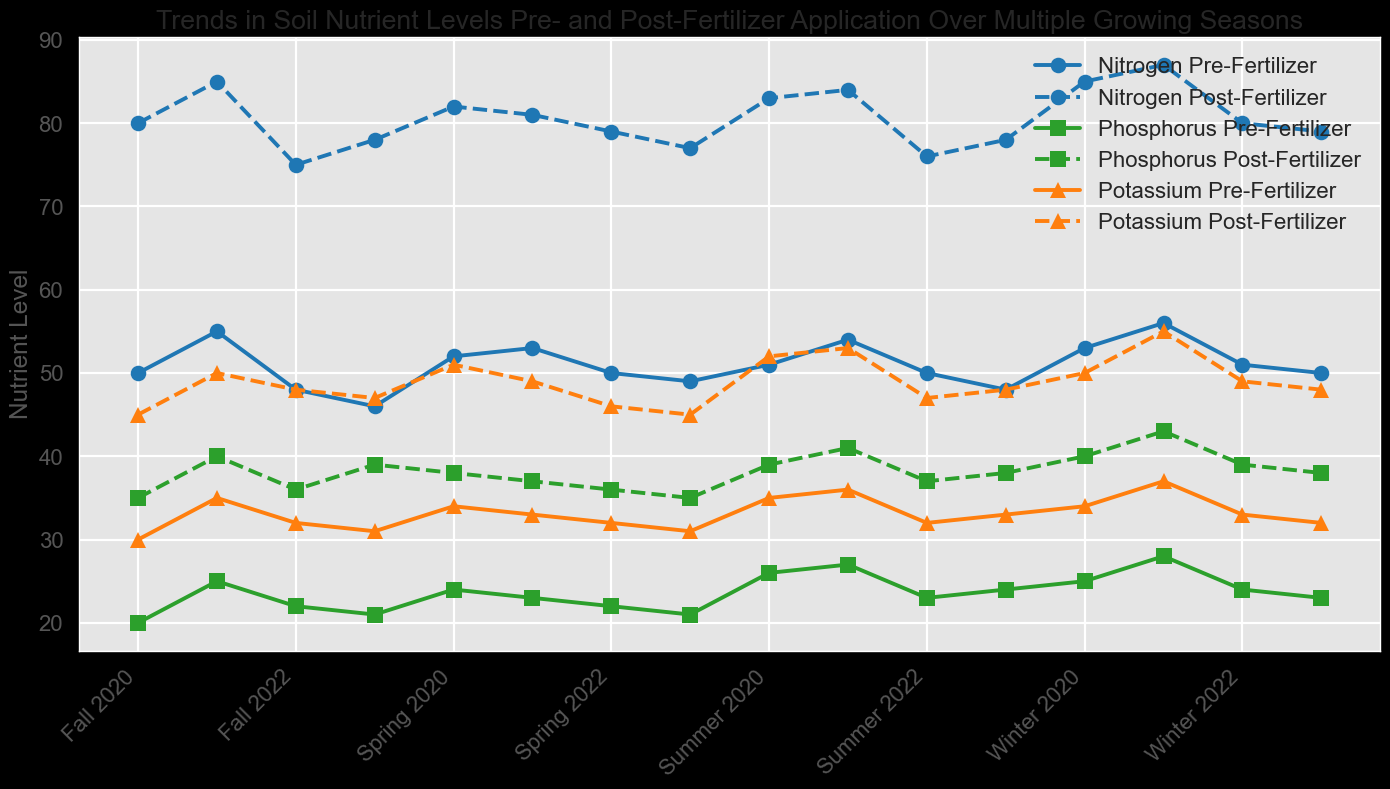What's the difference in Nitrogen levels between pre- and post-fertilizer applications in Summer 2023? To find the difference, we look at the Nitrogen levels pre-fertilizer and post-fertilizer in Summer 2023. They are 56 and 87 respectively. Subtract the pre-fertilizer value from the post-fertilizer value: 87 - 56 = 31
Answer: 31 Which season in 2021 has the highest post-fertilizer Potassium level? We examine each season in 2021 for post-fertilizer Potassium levels: Spring 2021 (51), Summer 2021 (49), Fall 2021 (46), and Winter 2021 (45). Comparing these values, Spring 2021 has the highest post-fertilizer Potassium level.
Answer: Spring 2021 What is the average post-fertilizer Phosphorus level in 2023? Look at the post-fertilizer Phosphorus levels for each season in 2023. They are Spring (40), Summer (43), Fall (39), and Winter (38). Add these values and divide by the number of seasons: (40 + 43 + 39 + 38) / 4 = 40
Answer: 40 Which nutrient shows the smallest increase from pre-fertilizer to post-fertilizer levels in Fall 2020? Check the differences for each nutrient: Nitrogen (75 - 48 = 27), Phosphorus (36 - 22 = 14), Potassium (48 - 32 = 16). Comparing these, Phosphorus shows the smallest increase in levels.
Answer: Phosphorus Compare the Phosphorus levels pre-fertilizer between Summer 2020 and Summer 2022. Which one is higher? Look at the pre-fertilizer Phosphorus levels in Summer 2020 (25) and Summer 2022 (27). Comparing these values, Summer 2022 is higher.
Answer: Summer 2022 In which season and year does Potassium pre-fertilizer level decrease for the first time compared to the previous season? Follow the pre-fertilizer Potassium levels across each season. The notable first decrease happens from Spring 2021 (34) to Summer 2021 (33).
Answer: Summer 2021 What is the difference in Phosphorus levels between pre- and post-fertilizer applications in Winter 2020? Subtract the pre-fertilizer level of Phosphorus in Winter 2020 (21) from the post-fertilizer level (39): 39 - 21 = 18
Answer: 18 Which nutrient has the most significant increase in post-fertilizer levels between Summer 2022 and Fall 2022? Compare post-fertilizer levels from Summer 2022 and Fall 2022 for each nutrient: Nitrogen (84 - 76 = 8), Phosphorus (41 - 37 = 4), Potassium (53 - 47 = 6). Nitrogen has the most significant increase.
Answer: Nitrogen 